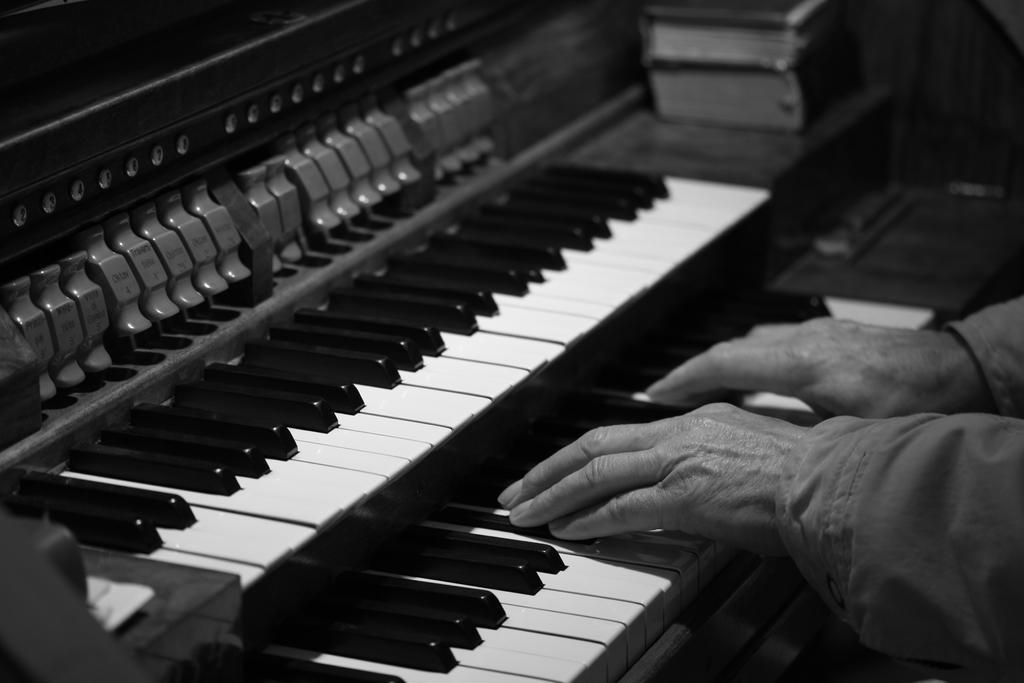How would you summarize this image in a sentence or two? In this picture we can see piano and hands of a person. At the top right corner they look like books. 